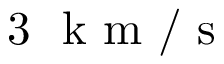Convert formula to latex. <formula><loc_0><loc_0><loc_500><loc_500>3 k m / s</formula> 